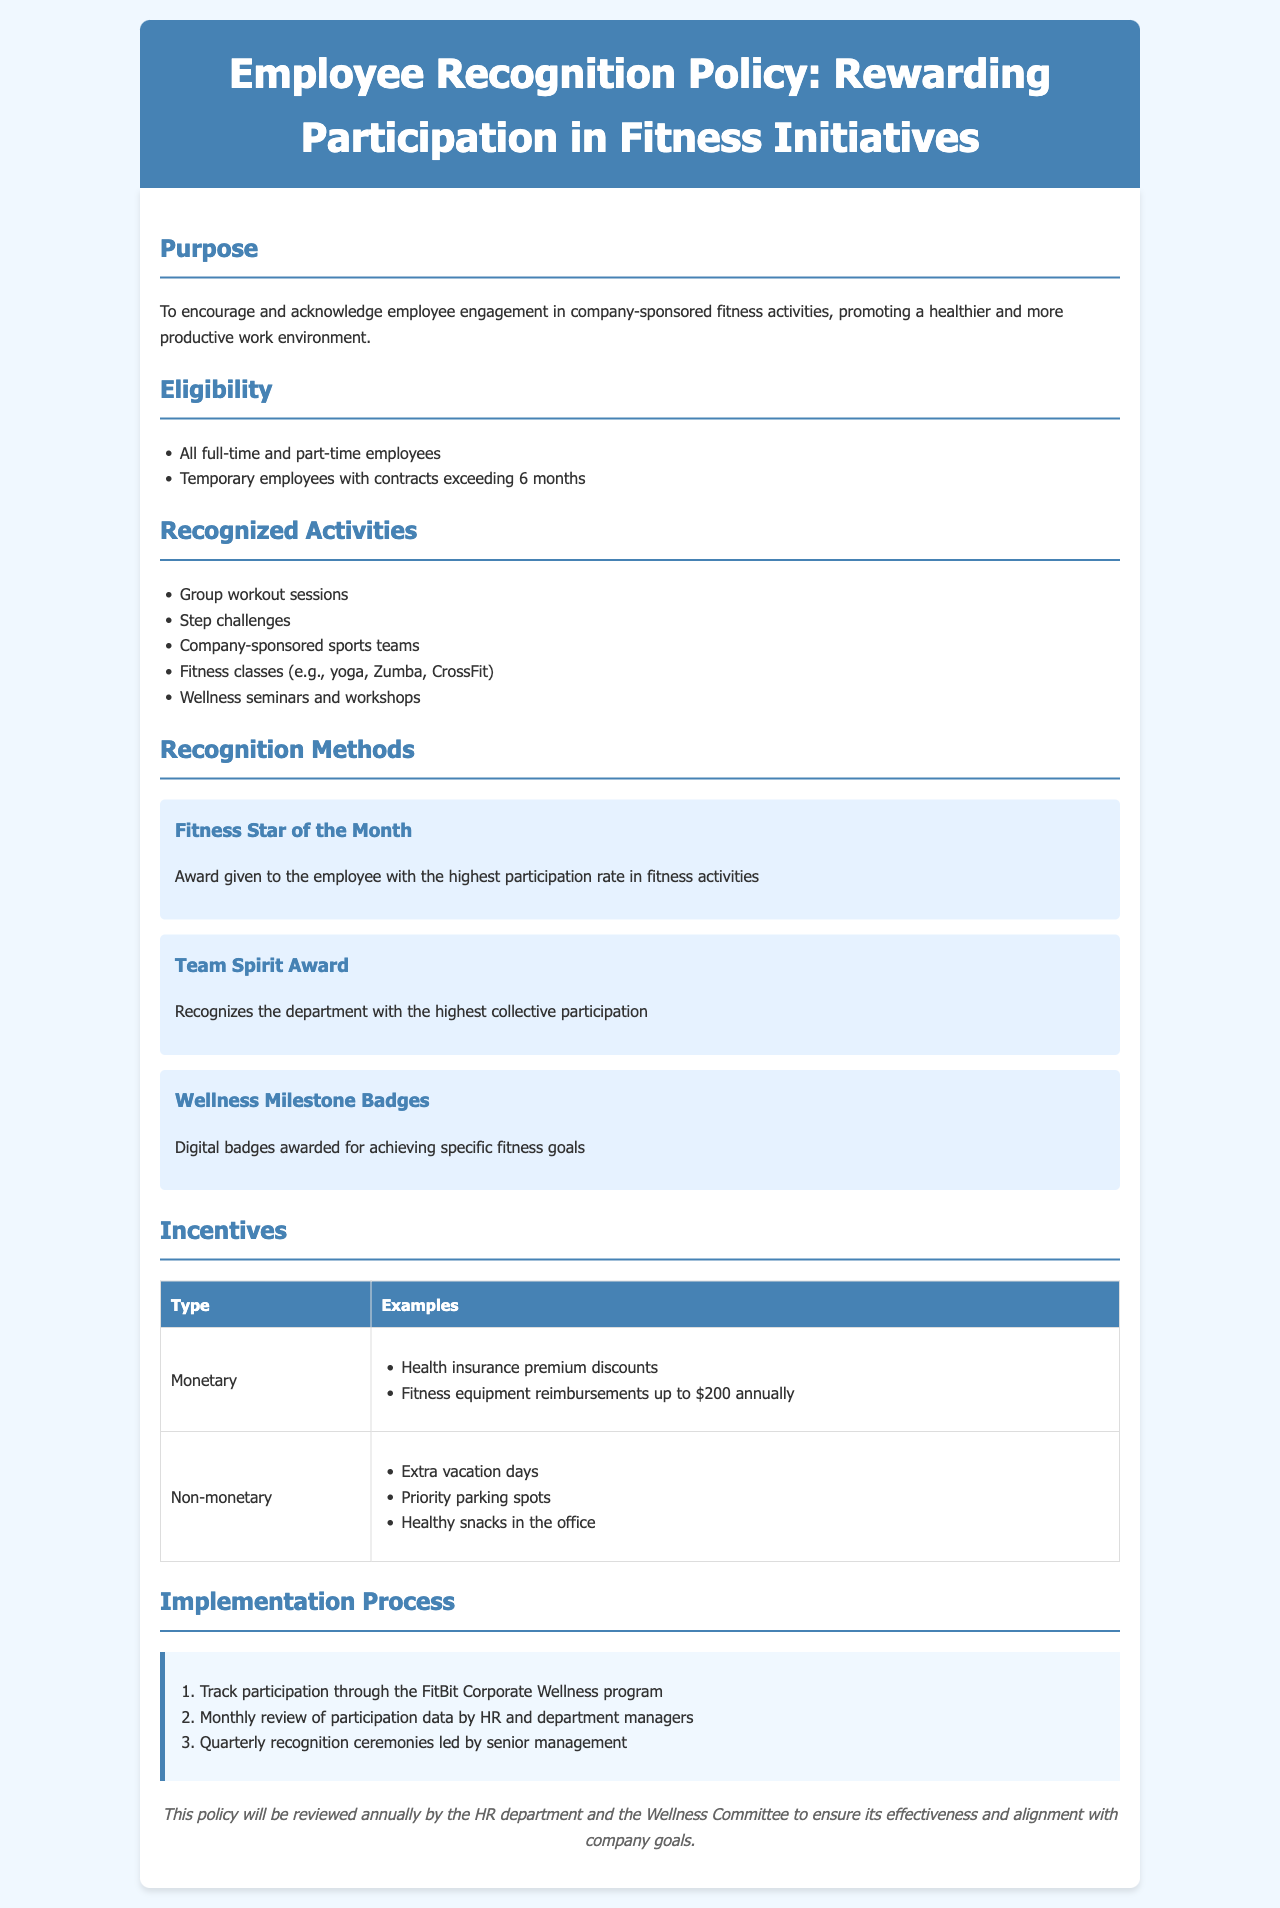What is the purpose of the policy? The purpose of the policy is to encourage and acknowledge employee engagement in company-sponsored fitness activities.
Answer: To encourage and acknowledge employee engagement in company-sponsored fitness activities Who is eligible for recognition under this policy? Eligibility includes all full-time and part-time employees and temporary employees with contracts exceeding 6 months.
Answer: All full-time and part-time employees and temporary employees with contracts exceeding 6 months What is the "Fitness Star of the Month"? The "Fitness Star of the Month" is an award given to the employee with the highest participation rate in fitness activities.
Answer: Award given to the employee with the highest participation rate in fitness activities What are examples of monetary incentives? Monetary incentives include health insurance premium discounts and fitness equipment reimbursements up to $200 annually.
Answer: Health insurance premium discounts, fitness equipment reimbursements up to $200 annually How often will the policy be reviewed? The policy will be reviewed annually by the HR department and the Wellness Committee.
Answer: Annually 